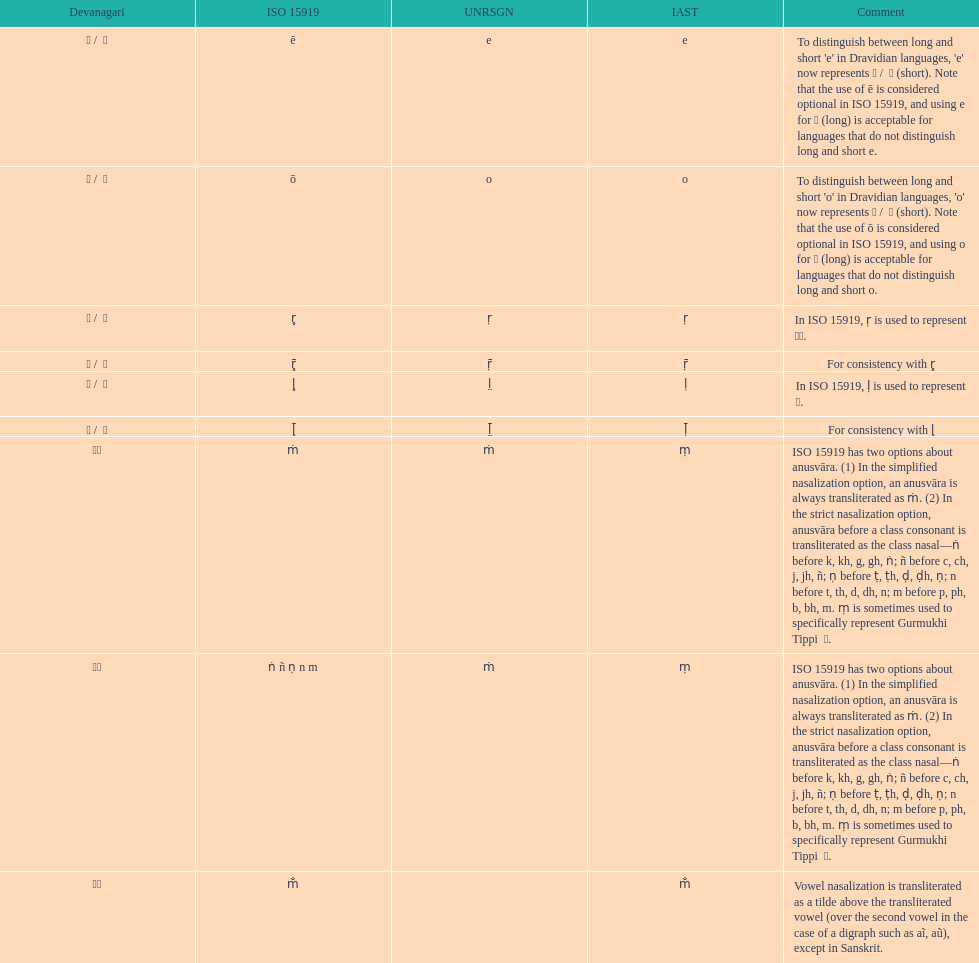Which devanagaria means the same as this iast letter: o? ओ / ो. 